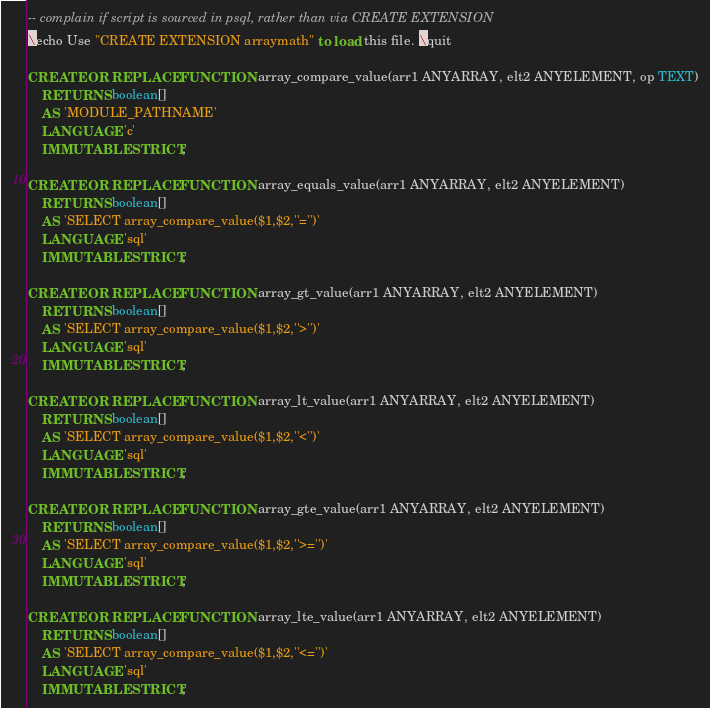Convert code to text. <code><loc_0><loc_0><loc_500><loc_500><_SQL_>-- complain if script is sourced in psql, rather than via CREATE EXTENSION
\echo Use "CREATE EXTENSION arraymath" to load this file. \quit

CREATE OR REPLACE FUNCTION array_compare_value(arr1 ANYARRAY, elt2 ANYELEMENT, op TEXT)
	RETURNS boolean[]
	AS 'MODULE_PATHNAME'
	LANGUAGE 'c'
	IMMUTABLE STRICT;
	
CREATE OR REPLACE FUNCTION array_equals_value(arr1 ANYARRAY, elt2 ANYELEMENT)
	RETURNS boolean[]
	AS 'SELECT array_compare_value($1,$2,''='')'
	LANGUAGE 'sql'
	IMMUTABLE STRICT;

CREATE OR REPLACE FUNCTION array_gt_value(arr1 ANYARRAY, elt2 ANYELEMENT)
	RETURNS boolean[]
	AS 'SELECT array_compare_value($1,$2,''>'')'
	LANGUAGE 'sql'
	IMMUTABLE STRICT;

CREATE OR REPLACE FUNCTION array_lt_value(arr1 ANYARRAY, elt2 ANYELEMENT)
	RETURNS boolean[]
	AS 'SELECT array_compare_value($1,$2,''<'')'
	LANGUAGE 'sql'
	IMMUTABLE STRICT;

CREATE OR REPLACE FUNCTION array_gte_value(arr1 ANYARRAY, elt2 ANYELEMENT)
	RETURNS boolean[]
	AS 'SELECT array_compare_value($1,$2,''>='')'
	LANGUAGE 'sql'
	IMMUTABLE STRICT;

CREATE OR REPLACE FUNCTION array_lte_value(arr1 ANYARRAY, elt2 ANYELEMENT)
	RETURNS boolean[]
	AS 'SELECT array_compare_value($1,$2,''<='')'
	LANGUAGE 'sql'
	IMMUTABLE STRICT;

</code> 